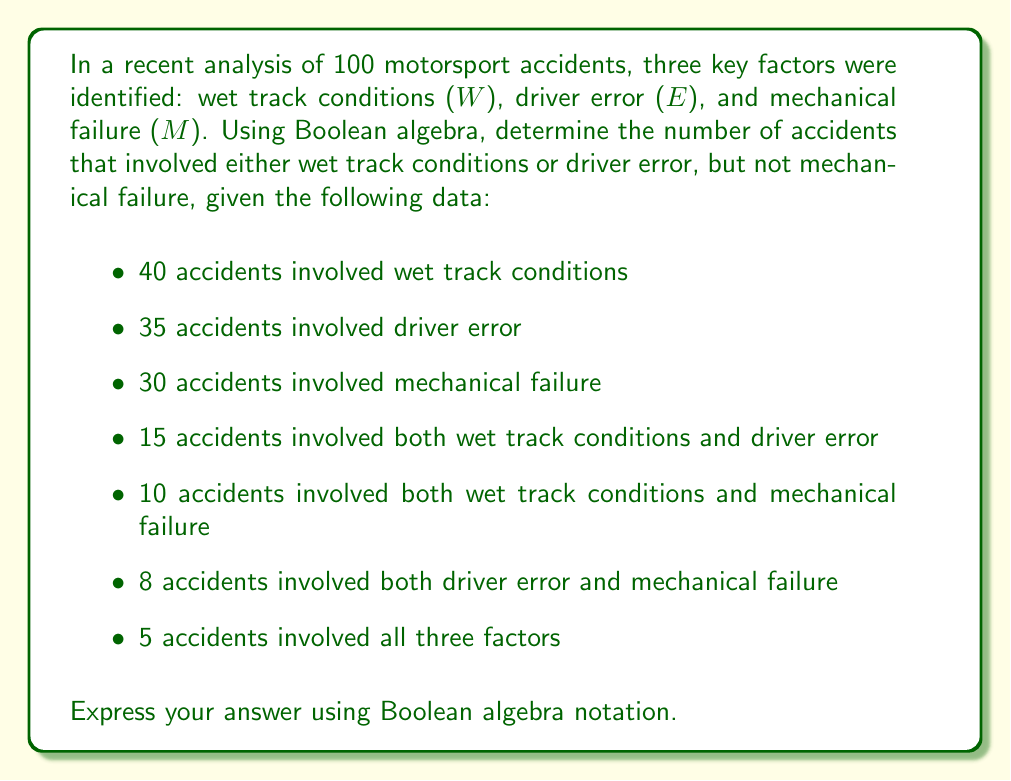Help me with this question. Let's approach this step-by-step using Boolean algebra:

1) First, we need to understand what the question is asking. We're looking for:
   $$(W \lor E) \land \overline{M}$$

2) We can use the inclusion-exclusion principle to solve this. Let's start with $W \lor E$:
   
   $$|W \lor E| = |W| + |E| - |W \land E|$$
   $$|W \lor E| = 40 + 35 - 15 = 60$$

3) Now, we need to subtract the accidents that also involved mechanical failure:
   
   $$|(W \lor E) \land \overline{M}| = |W \lor E| - |(W \lor E) \land M|$$

4) To find $|(W \lor E) \land M|$, we need to use the inclusion-exclusion principle again:
   
   $$|(W \lor E) \land M| = |W \land M| + |E \land M| - |W \land E \land M|$$
   $$|(W \lor E) \land M| = 10 + 8 - 5 = 13$$

5) Now we can complete our calculation:

   $$|(W \lor E) \land \overline{M}| = |W \lor E| - |(W \lor E) \land M|$$
   $$|(W \lor E) \land \overline{M}| = 60 - 13 = 47$$

Therefore, 47 accidents involved either wet track conditions or driver error, but not mechanical failure.
Answer: $|(W \lor E) \land \overline{M}| = 47$ 